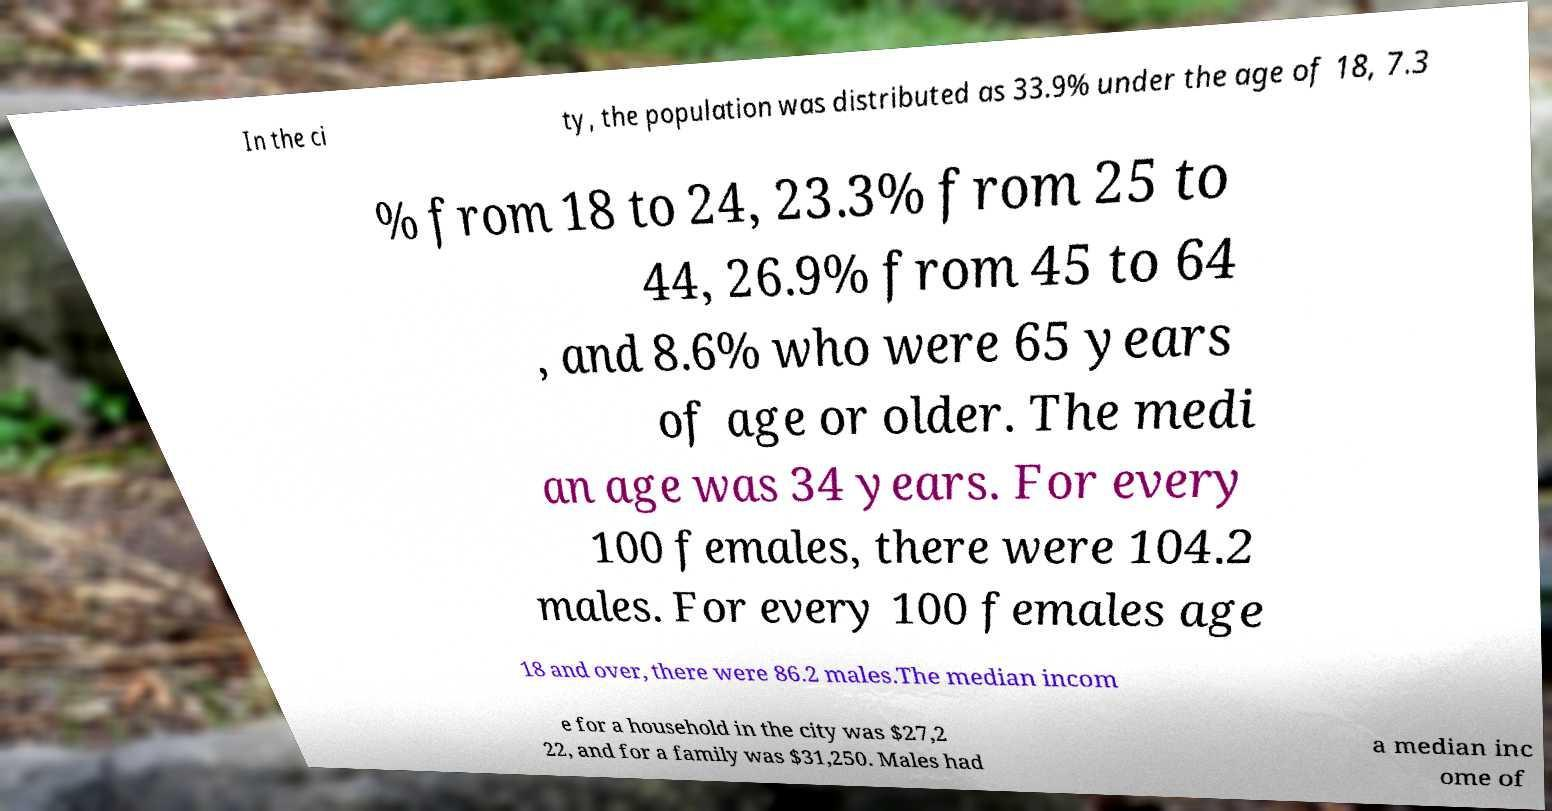Can you read and provide the text displayed in the image?This photo seems to have some interesting text. Can you extract and type it out for me? In the ci ty, the population was distributed as 33.9% under the age of 18, 7.3 % from 18 to 24, 23.3% from 25 to 44, 26.9% from 45 to 64 , and 8.6% who were 65 years of age or older. The medi an age was 34 years. For every 100 females, there were 104.2 males. For every 100 females age 18 and over, there were 86.2 males.The median incom e for a household in the city was $27,2 22, and for a family was $31,250. Males had a median inc ome of 